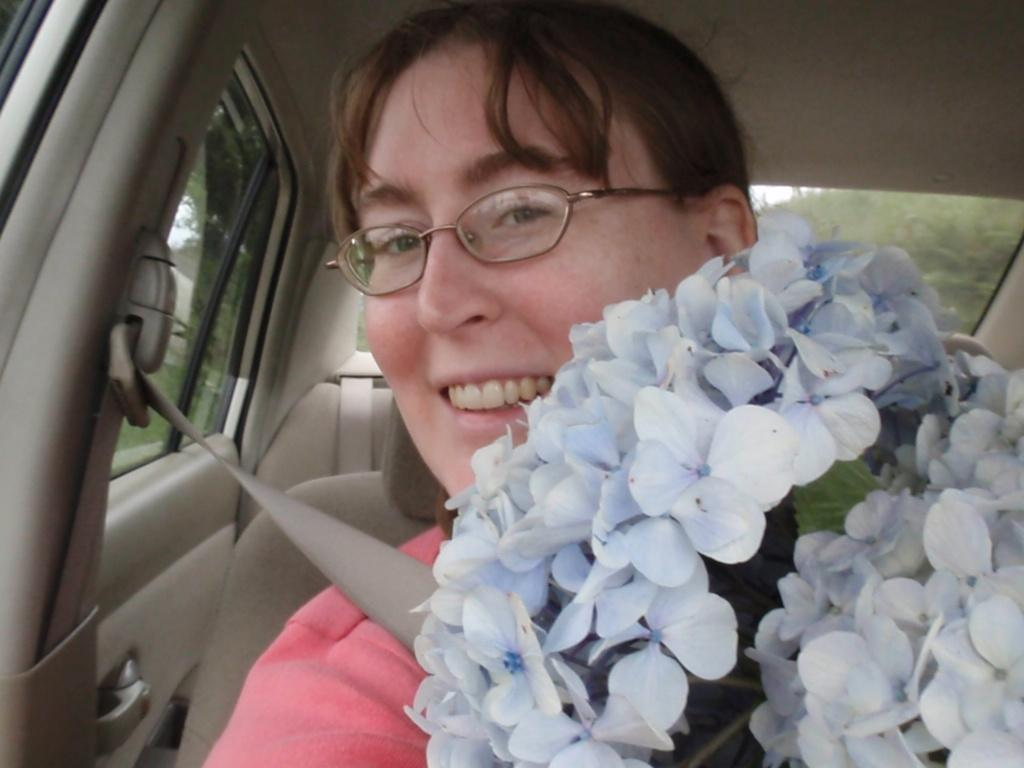What is the person in the car doing? The person is sitting in a car. Is the person taking any safety precautions while sitting in the car? Yes, the person is wearing a seat belt. What might the person be holding in their hands? The person is holding flowers. What can be seen in the background of the image? There are trees visible in the background. What is the name of the man holding cherries in the image? There is no man holding cherries in the image; it features a person sitting in a car holding flowers. 